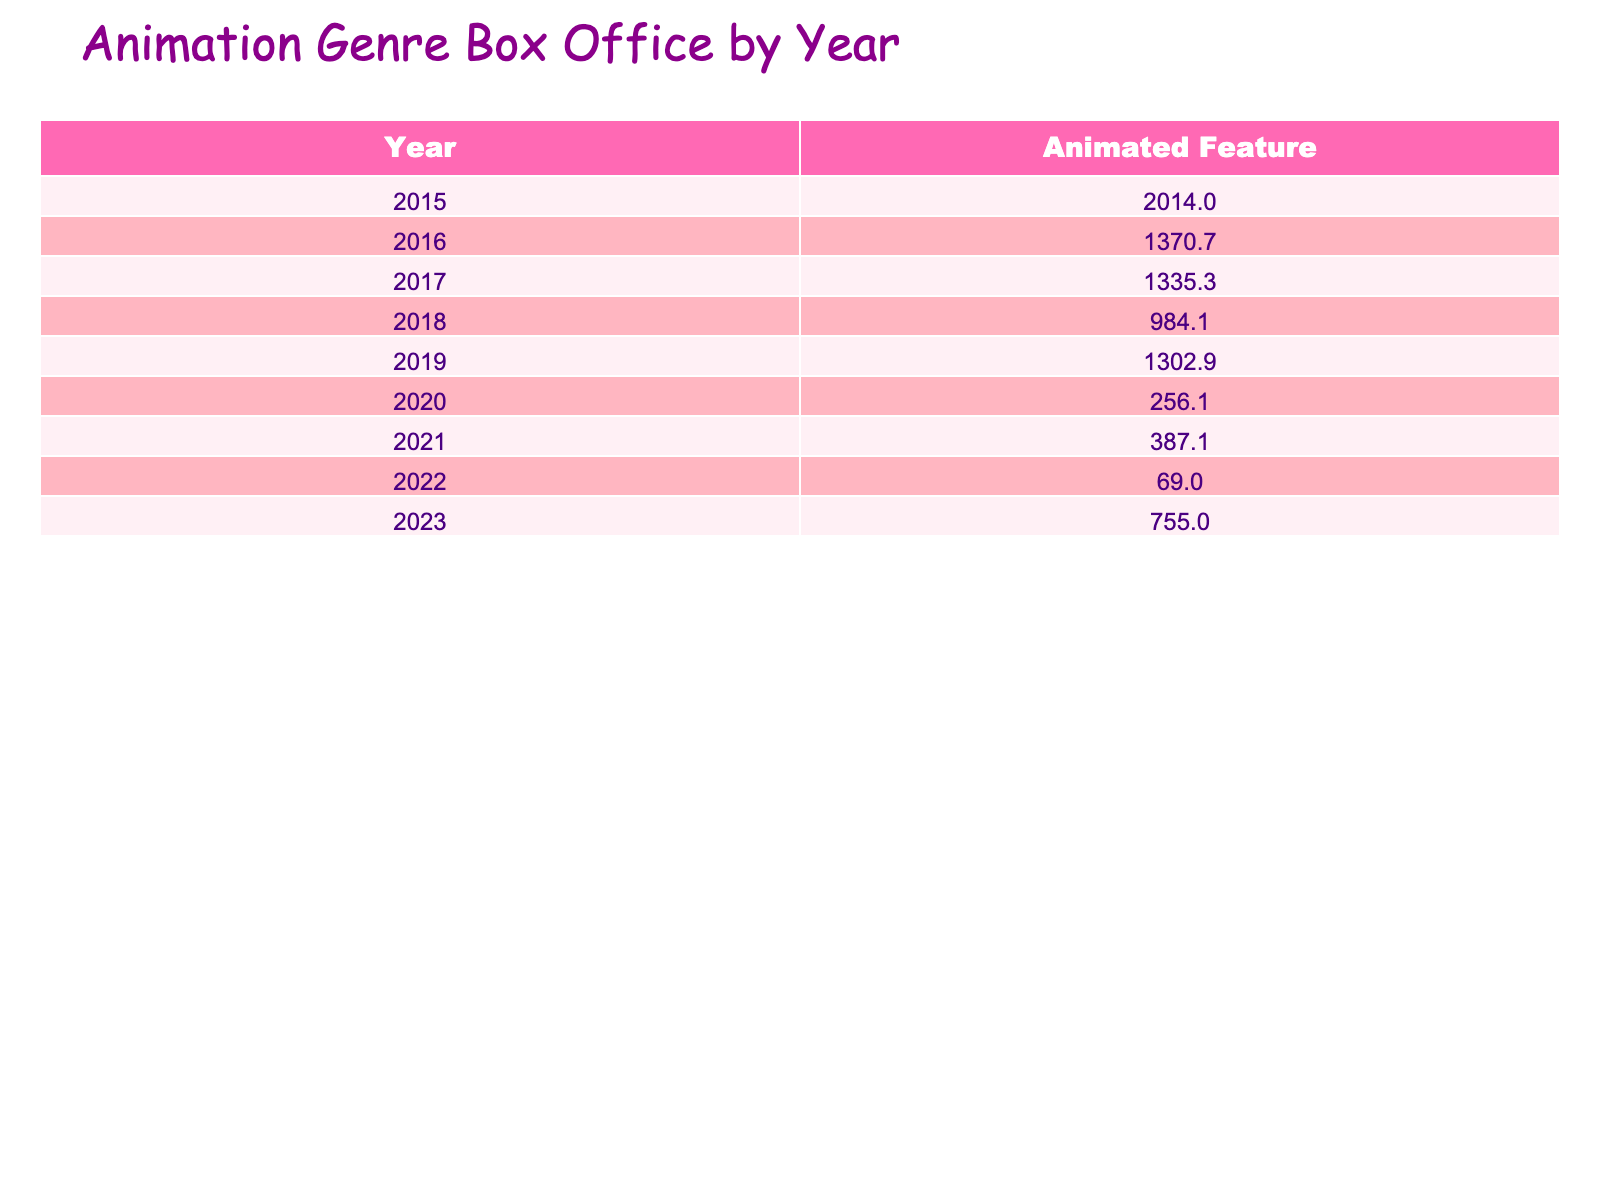What is the total box office gross for animated features in 2019? The box office gross for 2019 includes only one entry, Frozen II, which has a gross of 1302.9 million. Therefore, the total for 2019 is simply this figure.
Answer: 1302.9 Which animated feature made more than 800 million dollars in box office gross between 2015 and 2017? The films that grossed more than 800 million between 2015 and 2017 are Inside Out (857.6), Zootopia (1023.8), and Coco (807.1). Summing these, we see all three qualify.
Answer: Inside Out, Zootopia, Coco How many animated films were released in 2022? In 2022, there are two animated films listed: Turning Red and The Sea Beast. Thus, the count of animated films for that year is two.
Answer: 2 What is the average box office gross for animated features from 2020 to 2023? The box office gross figures from 2020 to 2023 are as follows: Soul (114.2), Onward (141.9), Raya and the Last Dragon (130.3), Encanto (256.8), Turning Red (30.0), The Sea Beast (39.0), Elemental (65.0), and Spider-Man: Across the Spider-Verse (690.0). Summing them gives 1415.2 and dividing by the eight films gives an average of 176.9.
Answer: 176.9 Did any animated films in 2022 have a critical rating above 7? In 2022, Turning Red has a critical rating of 7.1 and The Sea Beast has a rating of 7.5. Thus, both films meet the criterion of having a rating above 7.
Answer: Yes Which film has the highest critical rating among the animated features released from 2015 to 2023? The critical ratings from 2015 to 2023 show that Spider-Man: Across the Spider-Verse has the highest rating of 8.8. Checking the ratings reveals this as the top rating.
Answer: 8.8 What is the difference in box office gross between Minions and The Boss Baby? Minions has a box office gross of 1156.4 million, while The Boss Baby has 528.2 million. The difference can be calculated as 1156.4 - 528.2 = 628.2 million.
Answer: 628.2 How many animated features had a box office gross of less than 100 million from 2015 to 2023? The films Turning Red (30.0) and The Sea Beast (39.0) are the only two with a box office gross under 100 million, totaling two films within that category.
Answer: 2 What is the total critical rating for animated features released in 2018 and 2019? The critical ratings for the films released in 2018 (Spider-Man: Into the Spider-Verse, 8.4 and Incredibles 2, 7.6) sum up to 8.4 + 7.6 = 16.0. Frozen II from 2019 has a rating of 6.9. Adding them gives the total critical rating of 16.0 + 6.9 = 22.9.
Answer: 22.9 